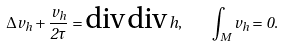<formula> <loc_0><loc_0><loc_500><loc_500>\Delta v _ { h } + \frac { v _ { h } } { 2 \tau } = \text {div} \, \text {div} \, h , \quad \int _ { M } v _ { h } = 0 .</formula> 